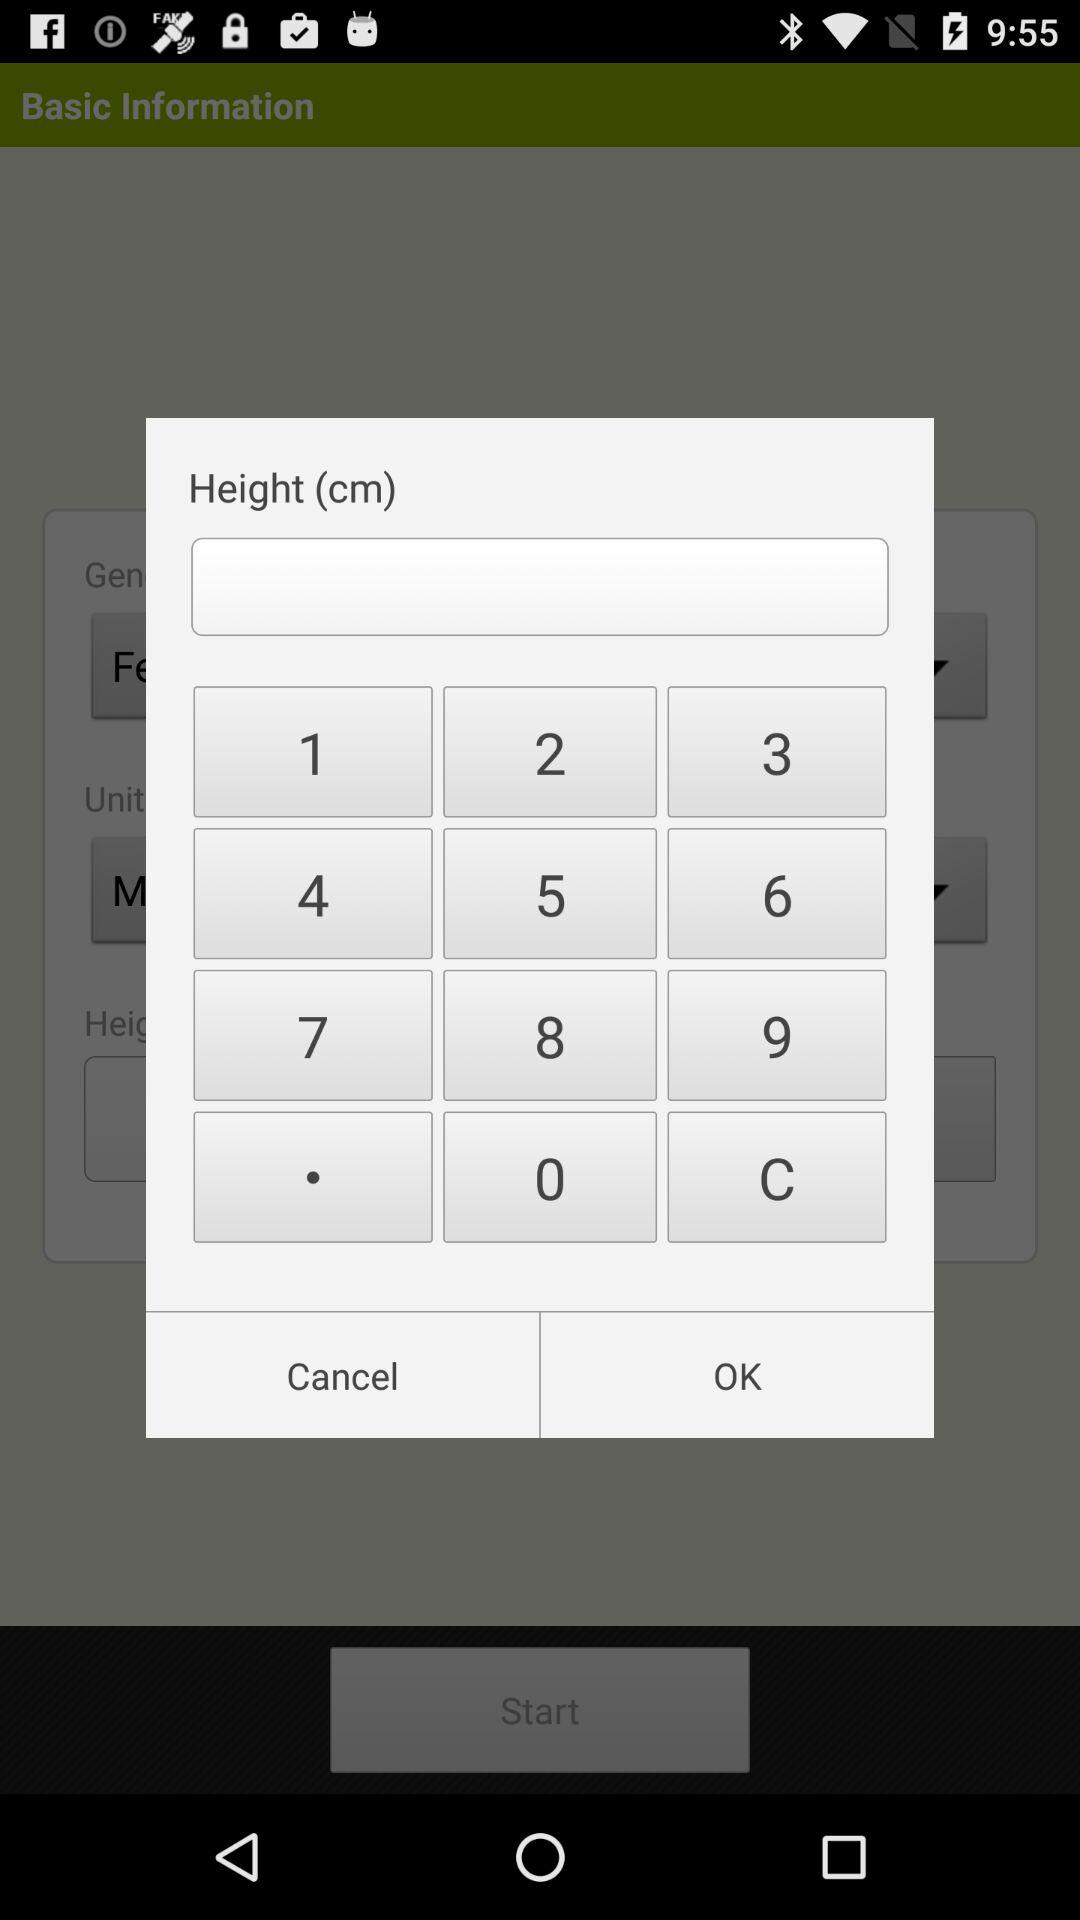In what unit is the height mentioned? The height is mentioned in centimetres. 